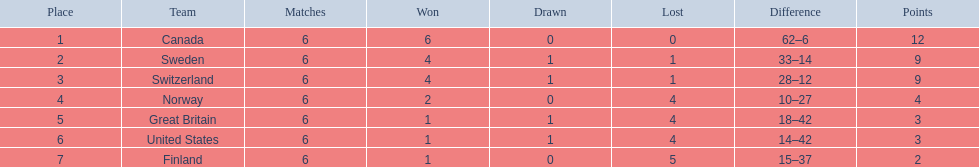Comparing finland and norway, which team has more match wins? Norway. 